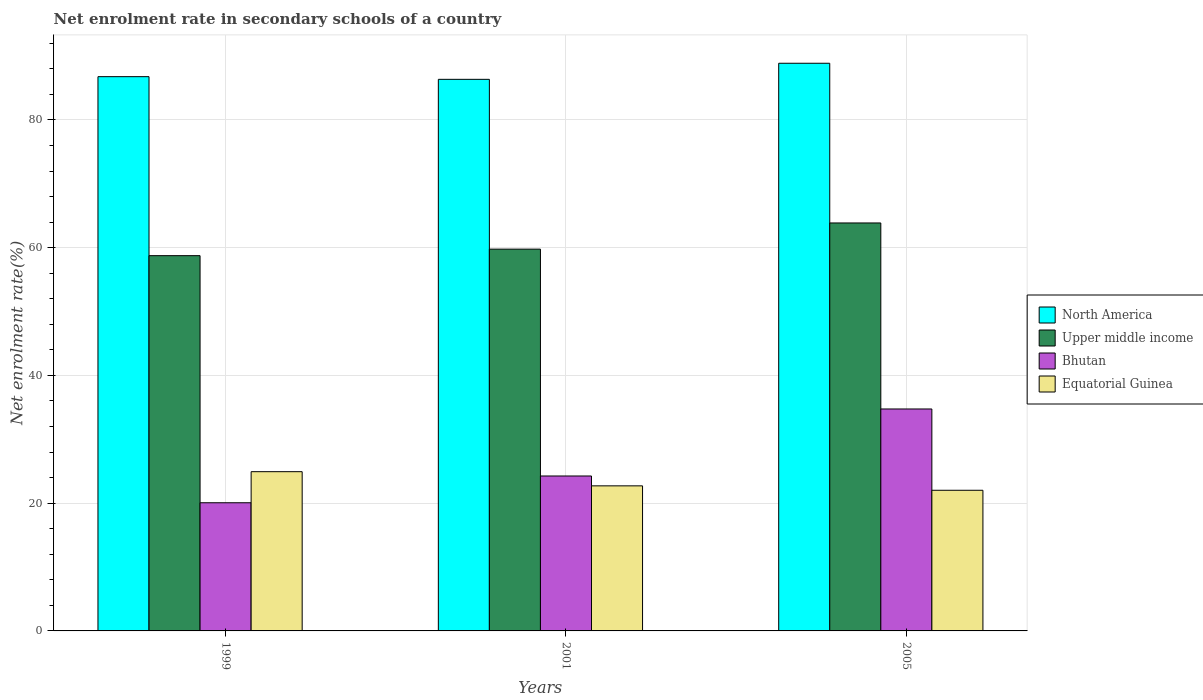How many different coloured bars are there?
Provide a short and direct response. 4. How many bars are there on the 3rd tick from the left?
Your answer should be compact. 4. How many bars are there on the 3rd tick from the right?
Make the answer very short. 4. In how many cases, is the number of bars for a given year not equal to the number of legend labels?
Ensure brevity in your answer.  0. What is the net enrolment rate in secondary schools in Bhutan in 1999?
Offer a terse response. 20.07. Across all years, what is the maximum net enrolment rate in secondary schools in Upper middle income?
Offer a terse response. 63.87. Across all years, what is the minimum net enrolment rate in secondary schools in Bhutan?
Offer a terse response. 20.07. In which year was the net enrolment rate in secondary schools in Equatorial Guinea maximum?
Your response must be concise. 1999. What is the total net enrolment rate in secondary schools in North America in the graph?
Ensure brevity in your answer.  262. What is the difference between the net enrolment rate in secondary schools in North America in 2001 and that in 2005?
Offer a terse response. -2.52. What is the difference between the net enrolment rate in secondary schools in Bhutan in 2005 and the net enrolment rate in secondary schools in Equatorial Guinea in 2001?
Your answer should be compact. 12.03. What is the average net enrolment rate in secondary schools in Upper middle income per year?
Give a very brief answer. 60.8. In the year 1999, what is the difference between the net enrolment rate in secondary schools in Equatorial Guinea and net enrolment rate in secondary schools in North America?
Keep it short and to the point. -61.84. In how many years, is the net enrolment rate in secondary schools in Equatorial Guinea greater than 36 %?
Provide a short and direct response. 0. What is the ratio of the net enrolment rate in secondary schools in Equatorial Guinea in 2001 to that in 2005?
Offer a terse response. 1.03. Is the net enrolment rate in secondary schools in North America in 1999 less than that in 2005?
Keep it short and to the point. Yes. What is the difference between the highest and the second highest net enrolment rate in secondary schools in Equatorial Guinea?
Your answer should be compact. 2.22. What is the difference between the highest and the lowest net enrolment rate in secondary schools in Bhutan?
Your answer should be compact. 14.68. In how many years, is the net enrolment rate in secondary schools in Equatorial Guinea greater than the average net enrolment rate in secondary schools in Equatorial Guinea taken over all years?
Your answer should be very brief. 1. Is it the case that in every year, the sum of the net enrolment rate in secondary schools in Equatorial Guinea and net enrolment rate in secondary schools in Bhutan is greater than the sum of net enrolment rate in secondary schools in Upper middle income and net enrolment rate in secondary schools in North America?
Provide a succinct answer. No. What does the 1st bar from the left in 2001 represents?
Provide a short and direct response. North America. What does the 2nd bar from the right in 2005 represents?
Your answer should be compact. Bhutan. Is it the case that in every year, the sum of the net enrolment rate in secondary schools in North America and net enrolment rate in secondary schools in Upper middle income is greater than the net enrolment rate in secondary schools in Equatorial Guinea?
Offer a very short reply. Yes. Are all the bars in the graph horizontal?
Keep it short and to the point. No. How many years are there in the graph?
Provide a succinct answer. 3. What is the difference between two consecutive major ticks on the Y-axis?
Provide a short and direct response. 20. How many legend labels are there?
Offer a very short reply. 4. How are the legend labels stacked?
Your answer should be compact. Vertical. What is the title of the graph?
Make the answer very short. Net enrolment rate in secondary schools of a country. What is the label or title of the Y-axis?
Your answer should be compact. Net enrolment rate(%). What is the Net enrolment rate(%) in North America in 1999?
Your answer should be very brief. 86.77. What is the Net enrolment rate(%) of Upper middle income in 1999?
Provide a succinct answer. 58.75. What is the Net enrolment rate(%) of Bhutan in 1999?
Make the answer very short. 20.07. What is the Net enrolment rate(%) of Equatorial Guinea in 1999?
Ensure brevity in your answer.  24.93. What is the Net enrolment rate(%) in North America in 2001?
Your answer should be very brief. 86.35. What is the Net enrolment rate(%) of Upper middle income in 2001?
Make the answer very short. 59.77. What is the Net enrolment rate(%) in Bhutan in 2001?
Provide a short and direct response. 24.26. What is the Net enrolment rate(%) of Equatorial Guinea in 2001?
Provide a short and direct response. 22.71. What is the Net enrolment rate(%) of North America in 2005?
Give a very brief answer. 88.87. What is the Net enrolment rate(%) in Upper middle income in 2005?
Offer a very short reply. 63.87. What is the Net enrolment rate(%) in Bhutan in 2005?
Your answer should be very brief. 34.75. What is the Net enrolment rate(%) of Equatorial Guinea in 2005?
Give a very brief answer. 22.02. Across all years, what is the maximum Net enrolment rate(%) of North America?
Your answer should be compact. 88.87. Across all years, what is the maximum Net enrolment rate(%) of Upper middle income?
Your response must be concise. 63.87. Across all years, what is the maximum Net enrolment rate(%) of Bhutan?
Your response must be concise. 34.75. Across all years, what is the maximum Net enrolment rate(%) of Equatorial Guinea?
Make the answer very short. 24.93. Across all years, what is the minimum Net enrolment rate(%) of North America?
Your answer should be compact. 86.35. Across all years, what is the minimum Net enrolment rate(%) in Upper middle income?
Your response must be concise. 58.75. Across all years, what is the minimum Net enrolment rate(%) in Bhutan?
Your answer should be very brief. 20.07. Across all years, what is the minimum Net enrolment rate(%) in Equatorial Guinea?
Your response must be concise. 22.02. What is the total Net enrolment rate(%) of North America in the graph?
Ensure brevity in your answer.  262. What is the total Net enrolment rate(%) of Upper middle income in the graph?
Make the answer very short. 182.39. What is the total Net enrolment rate(%) of Bhutan in the graph?
Provide a short and direct response. 79.07. What is the total Net enrolment rate(%) in Equatorial Guinea in the graph?
Offer a very short reply. 69.66. What is the difference between the Net enrolment rate(%) of North America in 1999 and that in 2001?
Keep it short and to the point. 0.42. What is the difference between the Net enrolment rate(%) of Upper middle income in 1999 and that in 2001?
Provide a short and direct response. -1.02. What is the difference between the Net enrolment rate(%) of Bhutan in 1999 and that in 2001?
Your response must be concise. -4.19. What is the difference between the Net enrolment rate(%) in Equatorial Guinea in 1999 and that in 2001?
Provide a succinct answer. 2.22. What is the difference between the Net enrolment rate(%) in North America in 1999 and that in 2005?
Ensure brevity in your answer.  -2.1. What is the difference between the Net enrolment rate(%) in Upper middle income in 1999 and that in 2005?
Provide a short and direct response. -5.12. What is the difference between the Net enrolment rate(%) of Bhutan in 1999 and that in 2005?
Offer a very short reply. -14.68. What is the difference between the Net enrolment rate(%) of Equatorial Guinea in 1999 and that in 2005?
Make the answer very short. 2.91. What is the difference between the Net enrolment rate(%) in North America in 2001 and that in 2005?
Offer a very short reply. -2.52. What is the difference between the Net enrolment rate(%) of Upper middle income in 2001 and that in 2005?
Your response must be concise. -4.1. What is the difference between the Net enrolment rate(%) in Bhutan in 2001 and that in 2005?
Your answer should be very brief. -10.49. What is the difference between the Net enrolment rate(%) of Equatorial Guinea in 2001 and that in 2005?
Ensure brevity in your answer.  0.69. What is the difference between the Net enrolment rate(%) in North America in 1999 and the Net enrolment rate(%) in Upper middle income in 2001?
Offer a very short reply. 27. What is the difference between the Net enrolment rate(%) of North America in 1999 and the Net enrolment rate(%) of Bhutan in 2001?
Offer a terse response. 62.52. What is the difference between the Net enrolment rate(%) in North America in 1999 and the Net enrolment rate(%) in Equatorial Guinea in 2001?
Give a very brief answer. 64.06. What is the difference between the Net enrolment rate(%) of Upper middle income in 1999 and the Net enrolment rate(%) of Bhutan in 2001?
Provide a short and direct response. 34.49. What is the difference between the Net enrolment rate(%) in Upper middle income in 1999 and the Net enrolment rate(%) in Equatorial Guinea in 2001?
Provide a short and direct response. 36.04. What is the difference between the Net enrolment rate(%) in Bhutan in 1999 and the Net enrolment rate(%) in Equatorial Guinea in 2001?
Your answer should be very brief. -2.65. What is the difference between the Net enrolment rate(%) in North America in 1999 and the Net enrolment rate(%) in Upper middle income in 2005?
Keep it short and to the point. 22.9. What is the difference between the Net enrolment rate(%) in North America in 1999 and the Net enrolment rate(%) in Bhutan in 2005?
Provide a succinct answer. 52.03. What is the difference between the Net enrolment rate(%) of North America in 1999 and the Net enrolment rate(%) of Equatorial Guinea in 2005?
Provide a succinct answer. 64.75. What is the difference between the Net enrolment rate(%) of Upper middle income in 1999 and the Net enrolment rate(%) of Bhutan in 2005?
Your answer should be very brief. 24. What is the difference between the Net enrolment rate(%) in Upper middle income in 1999 and the Net enrolment rate(%) in Equatorial Guinea in 2005?
Offer a terse response. 36.73. What is the difference between the Net enrolment rate(%) in Bhutan in 1999 and the Net enrolment rate(%) in Equatorial Guinea in 2005?
Offer a very short reply. -1.95. What is the difference between the Net enrolment rate(%) in North America in 2001 and the Net enrolment rate(%) in Upper middle income in 2005?
Offer a terse response. 22.48. What is the difference between the Net enrolment rate(%) of North America in 2001 and the Net enrolment rate(%) of Bhutan in 2005?
Offer a very short reply. 51.61. What is the difference between the Net enrolment rate(%) in North America in 2001 and the Net enrolment rate(%) in Equatorial Guinea in 2005?
Provide a succinct answer. 64.33. What is the difference between the Net enrolment rate(%) of Upper middle income in 2001 and the Net enrolment rate(%) of Bhutan in 2005?
Offer a terse response. 25.03. What is the difference between the Net enrolment rate(%) in Upper middle income in 2001 and the Net enrolment rate(%) in Equatorial Guinea in 2005?
Make the answer very short. 37.75. What is the difference between the Net enrolment rate(%) in Bhutan in 2001 and the Net enrolment rate(%) in Equatorial Guinea in 2005?
Your answer should be very brief. 2.24. What is the average Net enrolment rate(%) of North America per year?
Make the answer very short. 87.33. What is the average Net enrolment rate(%) in Upper middle income per year?
Your answer should be very brief. 60.8. What is the average Net enrolment rate(%) of Bhutan per year?
Provide a succinct answer. 26.36. What is the average Net enrolment rate(%) of Equatorial Guinea per year?
Make the answer very short. 23.22. In the year 1999, what is the difference between the Net enrolment rate(%) of North America and Net enrolment rate(%) of Upper middle income?
Your answer should be compact. 28.02. In the year 1999, what is the difference between the Net enrolment rate(%) of North America and Net enrolment rate(%) of Bhutan?
Keep it short and to the point. 66.71. In the year 1999, what is the difference between the Net enrolment rate(%) in North America and Net enrolment rate(%) in Equatorial Guinea?
Offer a very short reply. 61.84. In the year 1999, what is the difference between the Net enrolment rate(%) in Upper middle income and Net enrolment rate(%) in Bhutan?
Keep it short and to the point. 38.68. In the year 1999, what is the difference between the Net enrolment rate(%) in Upper middle income and Net enrolment rate(%) in Equatorial Guinea?
Your answer should be compact. 33.82. In the year 1999, what is the difference between the Net enrolment rate(%) in Bhutan and Net enrolment rate(%) in Equatorial Guinea?
Your response must be concise. -4.86. In the year 2001, what is the difference between the Net enrolment rate(%) of North America and Net enrolment rate(%) of Upper middle income?
Offer a terse response. 26.58. In the year 2001, what is the difference between the Net enrolment rate(%) in North America and Net enrolment rate(%) in Bhutan?
Provide a succinct answer. 62.1. In the year 2001, what is the difference between the Net enrolment rate(%) of North America and Net enrolment rate(%) of Equatorial Guinea?
Provide a succinct answer. 63.64. In the year 2001, what is the difference between the Net enrolment rate(%) in Upper middle income and Net enrolment rate(%) in Bhutan?
Offer a terse response. 35.52. In the year 2001, what is the difference between the Net enrolment rate(%) of Upper middle income and Net enrolment rate(%) of Equatorial Guinea?
Your response must be concise. 37.06. In the year 2001, what is the difference between the Net enrolment rate(%) of Bhutan and Net enrolment rate(%) of Equatorial Guinea?
Offer a very short reply. 1.54. In the year 2005, what is the difference between the Net enrolment rate(%) of North America and Net enrolment rate(%) of Upper middle income?
Offer a terse response. 25. In the year 2005, what is the difference between the Net enrolment rate(%) of North America and Net enrolment rate(%) of Bhutan?
Offer a terse response. 54.13. In the year 2005, what is the difference between the Net enrolment rate(%) of North America and Net enrolment rate(%) of Equatorial Guinea?
Make the answer very short. 66.85. In the year 2005, what is the difference between the Net enrolment rate(%) in Upper middle income and Net enrolment rate(%) in Bhutan?
Keep it short and to the point. 29.12. In the year 2005, what is the difference between the Net enrolment rate(%) of Upper middle income and Net enrolment rate(%) of Equatorial Guinea?
Your response must be concise. 41.85. In the year 2005, what is the difference between the Net enrolment rate(%) of Bhutan and Net enrolment rate(%) of Equatorial Guinea?
Ensure brevity in your answer.  12.73. What is the ratio of the Net enrolment rate(%) in North America in 1999 to that in 2001?
Provide a short and direct response. 1. What is the ratio of the Net enrolment rate(%) of Upper middle income in 1999 to that in 2001?
Keep it short and to the point. 0.98. What is the ratio of the Net enrolment rate(%) of Bhutan in 1999 to that in 2001?
Provide a short and direct response. 0.83. What is the ratio of the Net enrolment rate(%) in Equatorial Guinea in 1999 to that in 2001?
Provide a succinct answer. 1.1. What is the ratio of the Net enrolment rate(%) in North America in 1999 to that in 2005?
Your answer should be compact. 0.98. What is the ratio of the Net enrolment rate(%) of Upper middle income in 1999 to that in 2005?
Provide a succinct answer. 0.92. What is the ratio of the Net enrolment rate(%) in Bhutan in 1999 to that in 2005?
Offer a terse response. 0.58. What is the ratio of the Net enrolment rate(%) of Equatorial Guinea in 1999 to that in 2005?
Give a very brief answer. 1.13. What is the ratio of the Net enrolment rate(%) of North America in 2001 to that in 2005?
Your answer should be very brief. 0.97. What is the ratio of the Net enrolment rate(%) in Upper middle income in 2001 to that in 2005?
Give a very brief answer. 0.94. What is the ratio of the Net enrolment rate(%) of Bhutan in 2001 to that in 2005?
Make the answer very short. 0.7. What is the ratio of the Net enrolment rate(%) of Equatorial Guinea in 2001 to that in 2005?
Give a very brief answer. 1.03. What is the difference between the highest and the second highest Net enrolment rate(%) of North America?
Give a very brief answer. 2.1. What is the difference between the highest and the second highest Net enrolment rate(%) of Upper middle income?
Make the answer very short. 4.1. What is the difference between the highest and the second highest Net enrolment rate(%) in Bhutan?
Your answer should be compact. 10.49. What is the difference between the highest and the second highest Net enrolment rate(%) in Equatorial Guinea?
Provide a succinct answer. 2.22. What is the difference between the highest and the lowest Net enrolment rate(%) of North America?
Give a very brief answer. 2.52. What is the difference between the highest and the lowest Net enrolment rate(%) of Upper middle income?
Give a very brief answer. 5.12. What is the difference between the highest and the lowest Net enrolment rate(%) of Bhutan?
Provide a succinct answer. 14.68. What is the difference between the highest and the lowest Net enrolment rate(%) of Equatorial Guinea?
Offer a very short reply. 2.91. 